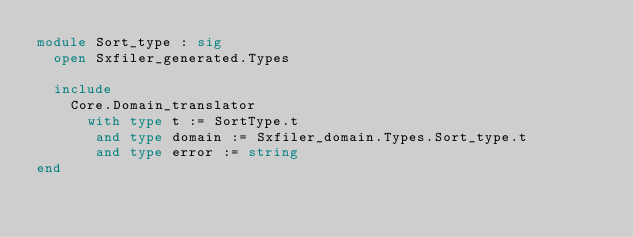<code> <loc_0><loc_0><loc_500><loc_500><_OCaml_>module Sort_type : sig
  open Sxfiler_generated.Types

  include
    Core.Domain_translator
      with type t := SortType.t
       and type domain := Sxfiler_domain.Types.Sort_type.t
       and type error := string
end
</code> 